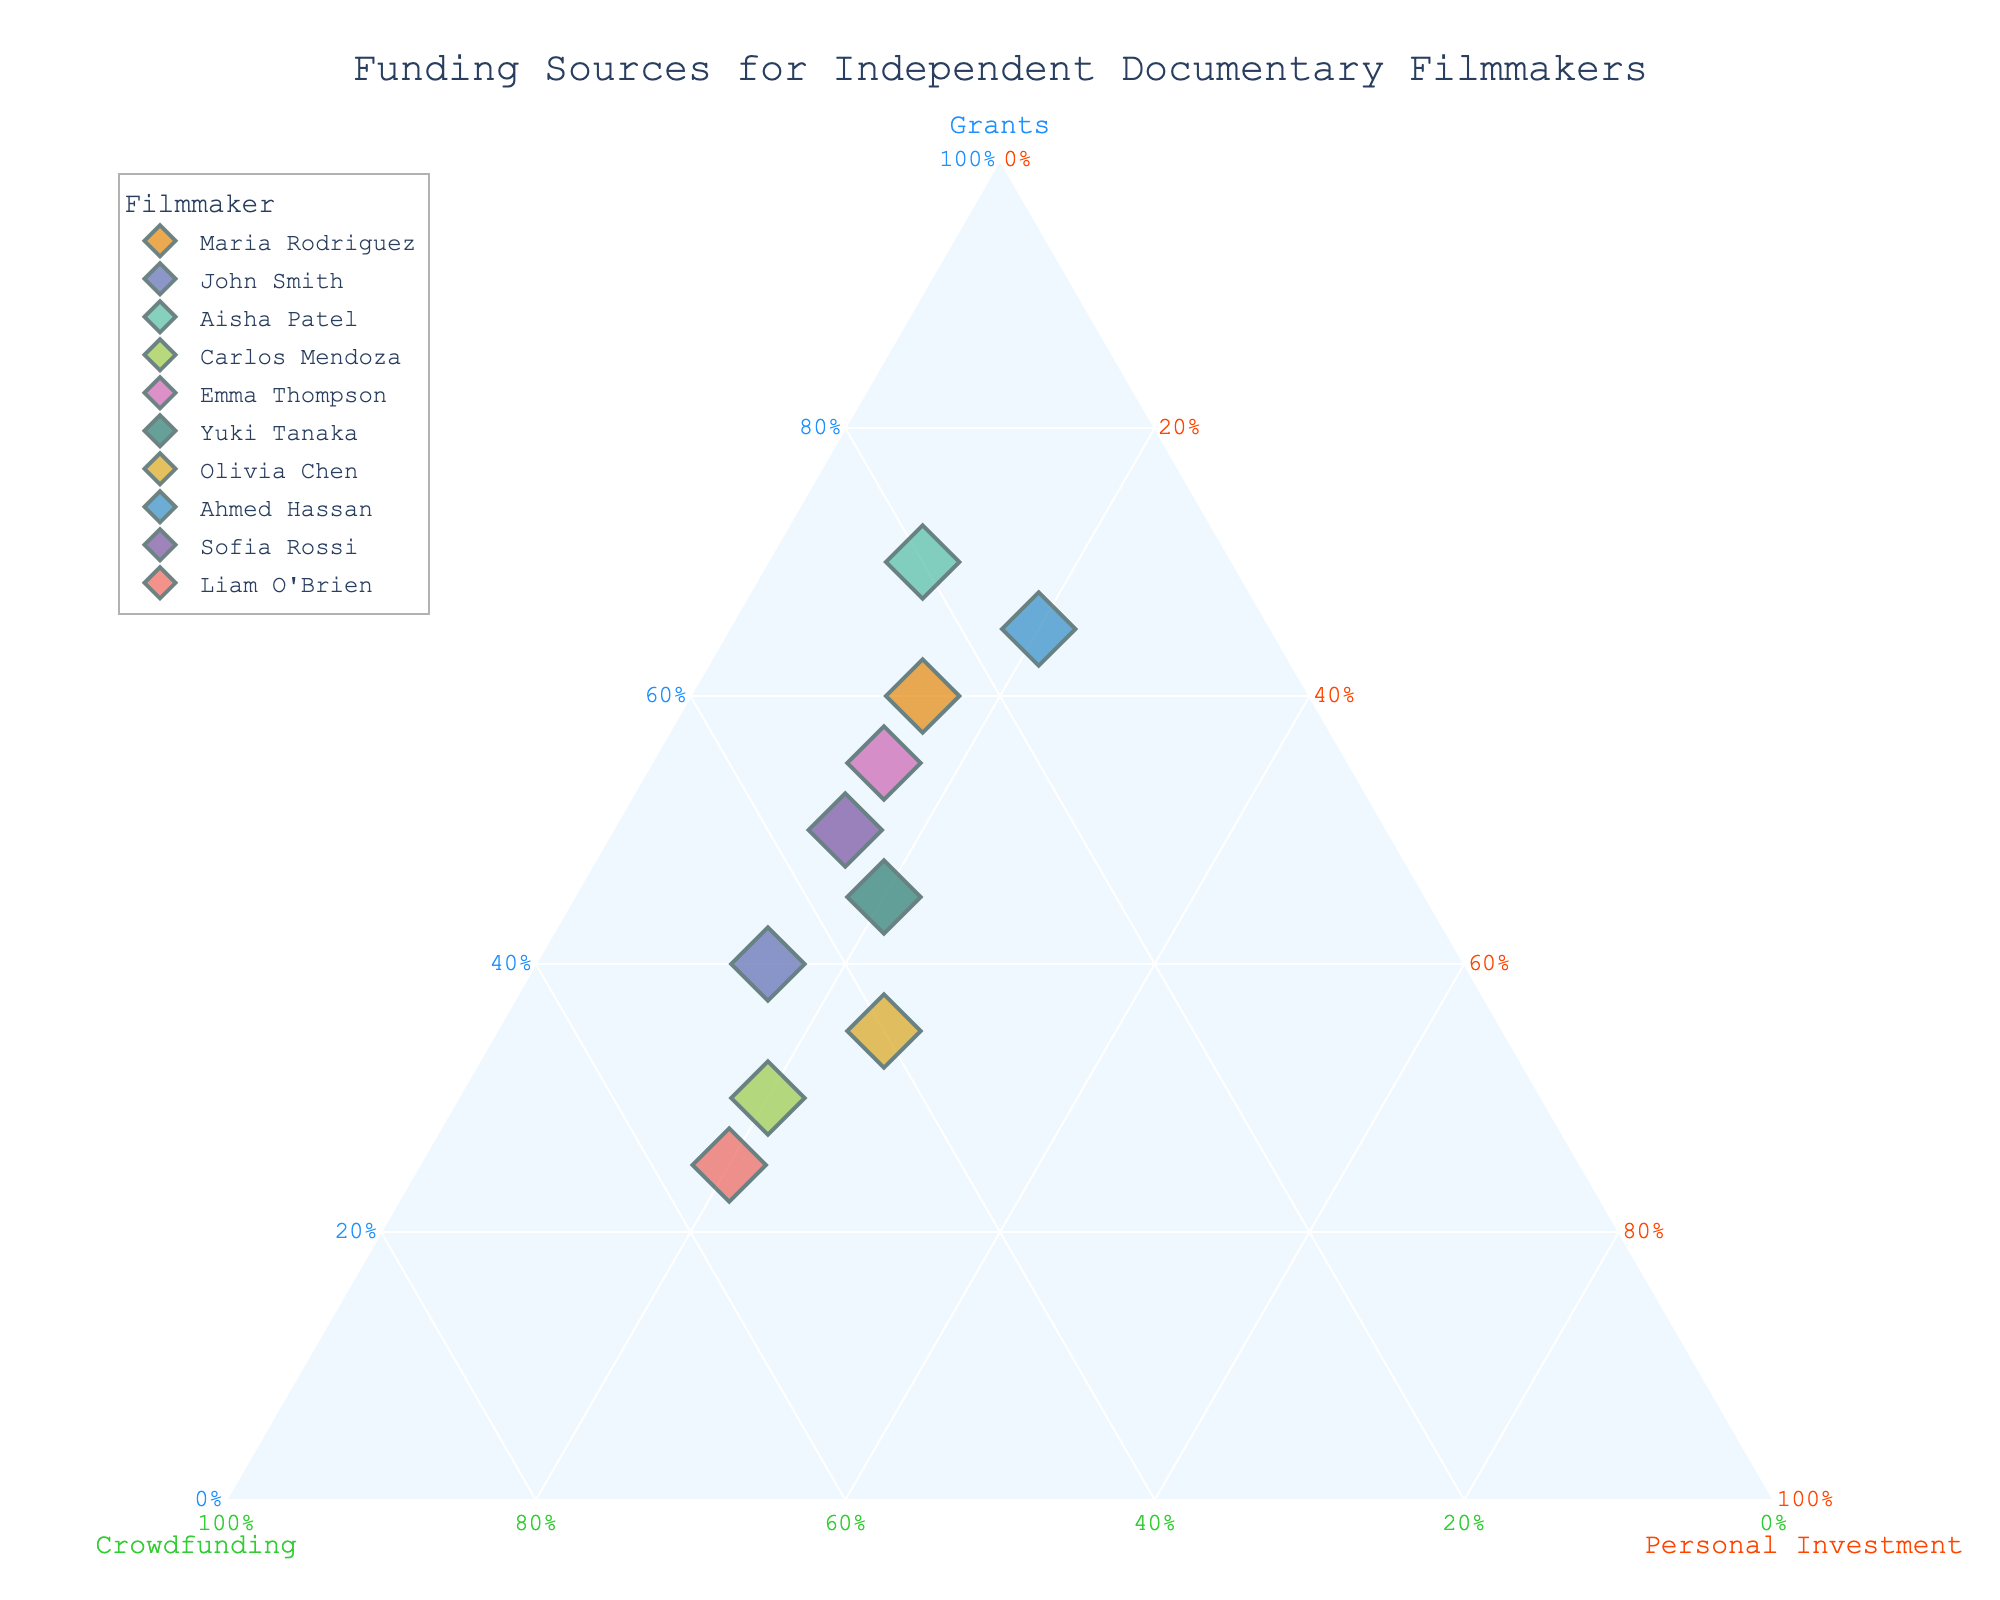How many documentary filmmakers are represented in the plot? Count the number of different filmmakers labeled on the plot.
Answer: 10 Which filmmaker has the highest proportion of grants as a funding source? Identify the point that is closest to the vertex labeled "Grants" to see which filmmaker has the highest proportion of grants.
Answer: Aisha Patel What is the average proportion of crowdfunding across all documentary filmmakers? Sum the proportions of crowdfunding for each filmmaker and then divide by the total number of filmmakers.
Answer: 35% Who relies more on personal investment, Carlos Mendoza or Emma Thompson? Compare the positions of Carlos Mendoza and Emma Thompson relative to the "Personal Investment" axis.
Answer: Carlos Mendoza What funding source is the least used by Olivia Chen? Identify the smallest proportion of the three funding sources (Grants, Crowdfunding, Personal Investment) for Olivia Chen.
Answer: Grants Which filmmakers have approximately equal reliance on grants and crowdfunding? Look for points that are equidistant from the "Grants" and "Crowdfunding" vertices.
Answer: None How does the funding proportion of Liam O'Brien compare to Ahmed Hassan in terms of crowdfunding? Compare the proportions of crowdfunding between Liam O'Brien and Ahmed Hassan based on their positions relative to the "Crowdfunding" axis.
Answer: Liam O'Brien has more What is the median proportion of personal investment among the filmmakers? Arrange the proportions of personal investment in ascending order and find the middle value.
Answer: 17.5% How does Emma Thompson's funding distribution compare to Maria Rodriguez? Compare the relative positions of Emma Thompson and Maria Rodriguez across all three funding sources.
Answer: Maria Rodriguez relies more on grants than Emma Thompson Which direction would you move a point to increase its proportion of personal investment? Determine which relative direction towards the "Personal Investment" vertex increases the proportion of personal investment.
Answer: Towards "Personal Investment" vertex 